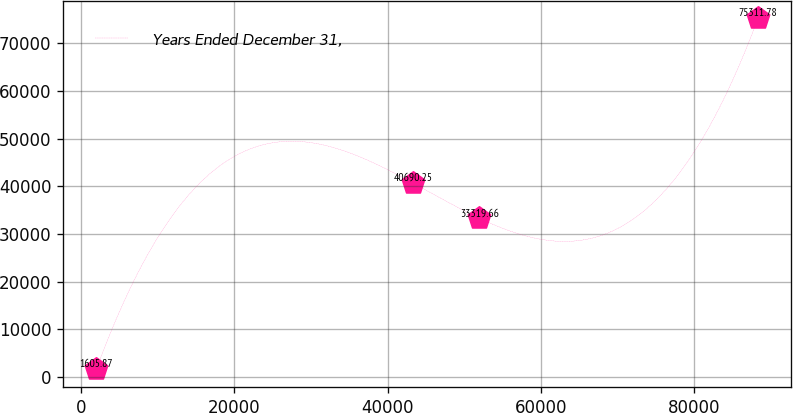<chart> <loc_0><loc_0><loc_500><loc_500><line_chart><ecel><fcel>Years Ended December 31,<nl><fcel>1986.36<fcel>1605.87<nl><fcel>43343.4<fcel>40690.2<nl><fcel>51982.5<fcel>33319.7<nl><fcel>88378<fcel>75311.8<nl></chart> 